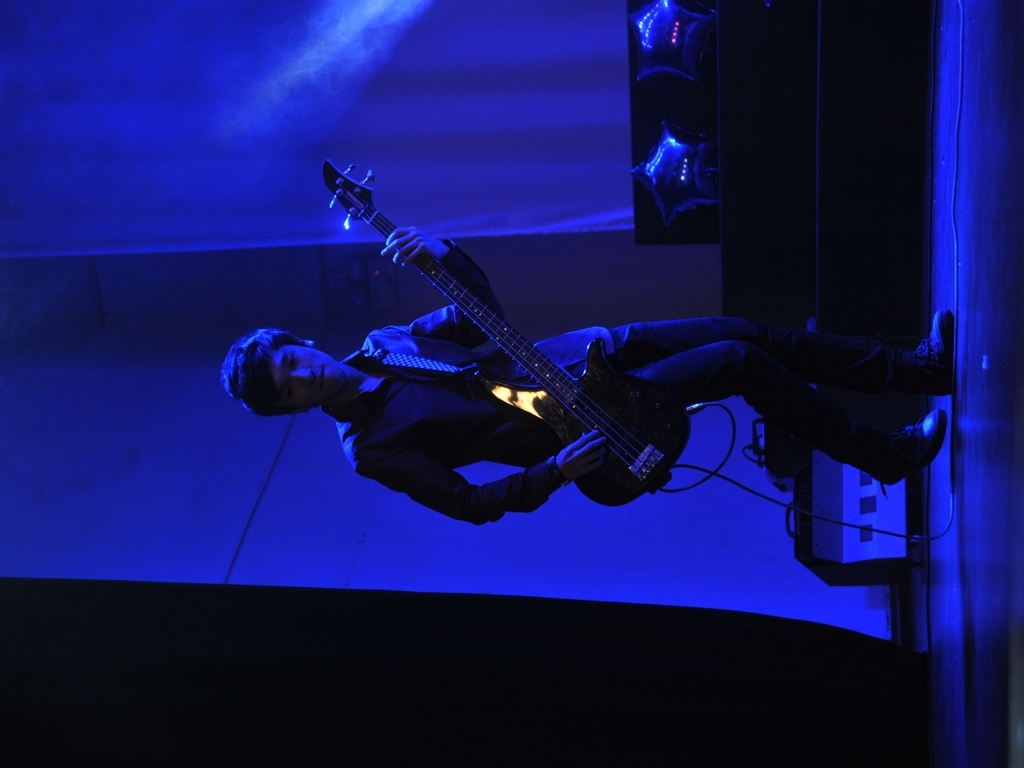What emotions does this image evoke about the performance? The solitary figure of the bassist, combined with the stark contrast of light and shadow, evokes a sense of introspection and passion. The intensity of the blue lighting adds a layer of coolness and introspection, suggesting a performance that is both energetic and emotionally resonant. It conveys a narrative of dedication and absorption in the art of music. 